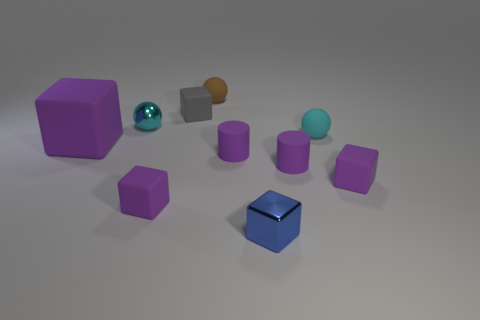Subtract all gray spheres. How many purple blocks are left? 3 Subtract all blue cubes. How many cubes are left? 4 Subtract all yellow blocks. Subtract all brown cylinders. How many blocks are left? 5 Subtract all cylinders. How many objects are left? 8 Add 7 tiny purple cubes. How many tiny purple cubes are left? 9 Add 2 tiny cylinders. How many tiny cylinders exist? 4 Subtract 0 green blocks. How many objects are left? 10 Subtract all small purple rubber blocks. Subtract all matte objects. How many objects are left? 0 